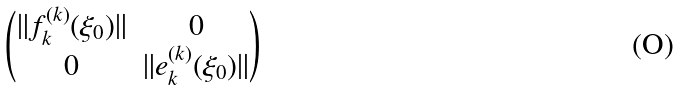<formula> <loc_0><loc_0><loc_500><loc_500>\begin{pmatrix} \| f ^ { ( k ) } _ { k } ( \xi _ { 0 } ) \| & 0 \\ 0 & \| e ^ { ( k ) } _ { k } ( \xi _ { 0 } ) \| \end{pmatrix}</formula> 